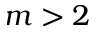Convert formula to latex. <formula><loc_0><loc_0><loc_500><loc_500>m > 2</formula> 